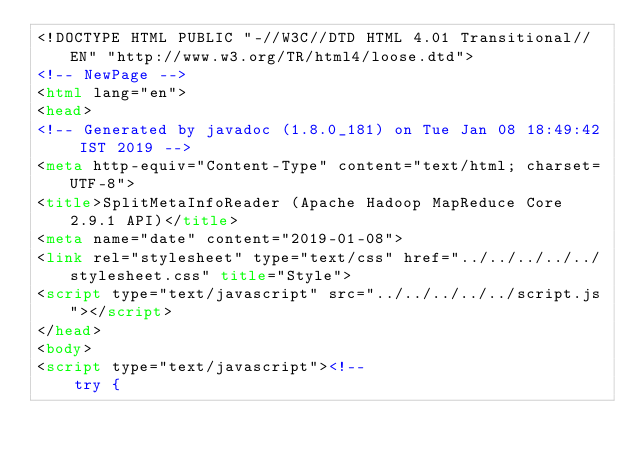Convert code to text. <code><loc_0><loc_0><loc_500><loc_500><_HTML_><!DOCTYPE HTML PUBLIC "-//W3C//DTD HTML 4.01 Transitional//EN" "http://www.w3.org/TR/html4/loose.dtd">
<!-- NewPage -->
<html lang="en">
<head>
<!-- Generated by javadoc (1.8.0_181) on Tue Jan 08 18:49:42 IST 2019 -->
<meta http-equiv="Content-Type" content="text/html; charset=UTF-8">
<title>SplitMetaInfoReader (Apache Hadoop MapReduce Core 2.9.1 API)</title>
<meta name="date" content="2019-01-08">
<link rel="stylesheet" type="text/css" href="../../../../../stylesheet.css" title="Style">
<script type="text/javascript" src="../../../../../script.js"></script>
</head>
<body>
<script type="text/javascript"><!--
    try {</code> 